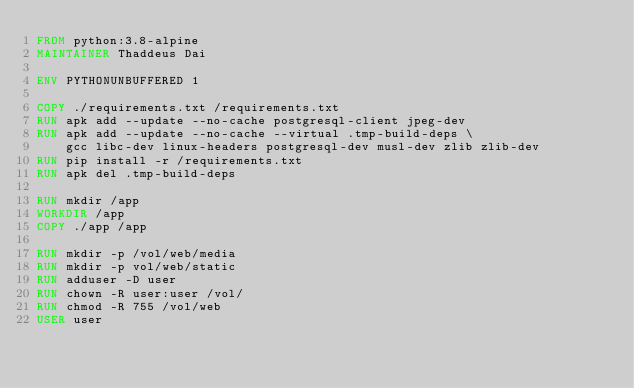<code> <loc_0><loc_0><loc_500><loc_500><_Dockerfile_>FROM python:3.8-alpine
MAINTAINER Thaddeus Dai

ENV PYTHONUNBUFFERED 1

COPY ./requirements.txt /requirements.txt
RUN apk add --update --no-cache postgresql-client jpeg-dev
RUN apk add --update --no-cache --virtual .tmp-build-deps \
    gcc libc-dev linux-headers postgresql-dev musl-dev zlib zlib-dev
RUN pip install -r /requirements.txt
RUN apk del .tmp-build-deps

RUN mkdir /app
WORKDIR /app
COPY ./app /app

RUN mkdir -p /vol/web/media
RUN mkdir -p vol/web/static
RUN adduser -D user
RUN chown -R user:user /vol/
RUN chmod -R 755 /vol/web
USER user</code> 